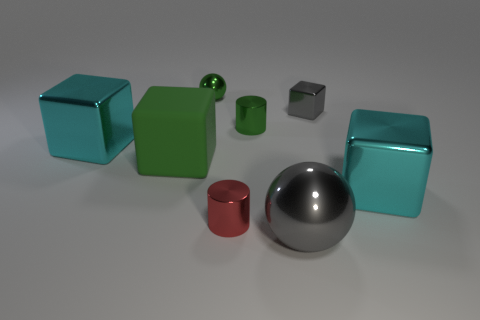Subtract 1 cubes. How many cubes are left? 3 Add 1 metal cylinders. How many objects exist? 9 Subtract all blue cubes. Subtract all yellow cylinders. How many cubes are left? 4 Subtract all cylinders. How many objects are left? 6 Add 6 large brown rubber objects. How many large brown rubber objects exist? 6 Subtract 0 yellow spheres. How many objects are left? 8 Subtract all large red shiny cylinders. Subtract all tiny metal cylinders. How many objects are left? 6 Add 6 rubber cubes. How many rubber cubes are left? 7 